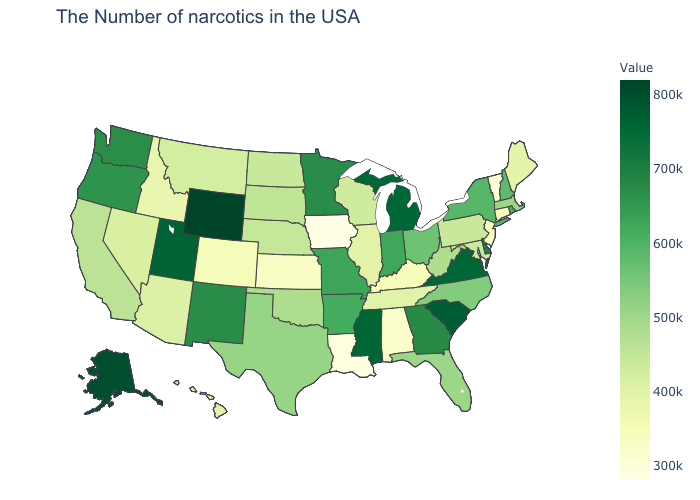Does Iowa have the lowest value in the USA?
Write a very short answer. Yes. Which states have the lowest value in the Northeast?
Short answer required. Vermont. 